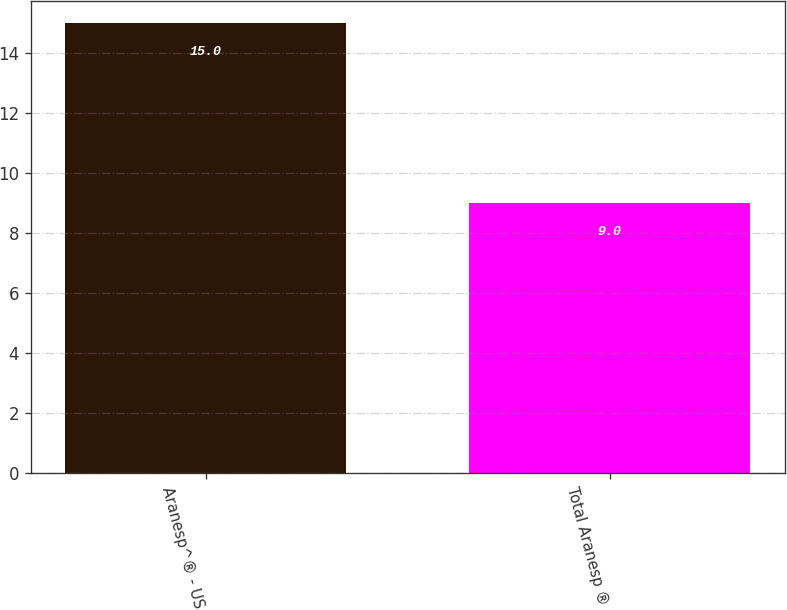<chart> <loc_0><loc_0><loc_500><loc_500><bar_chart><fcel>Aranesp^® - US<fcel>Total Aranesp ®<nl><fcel>15<fcel>9<nl></chart> 